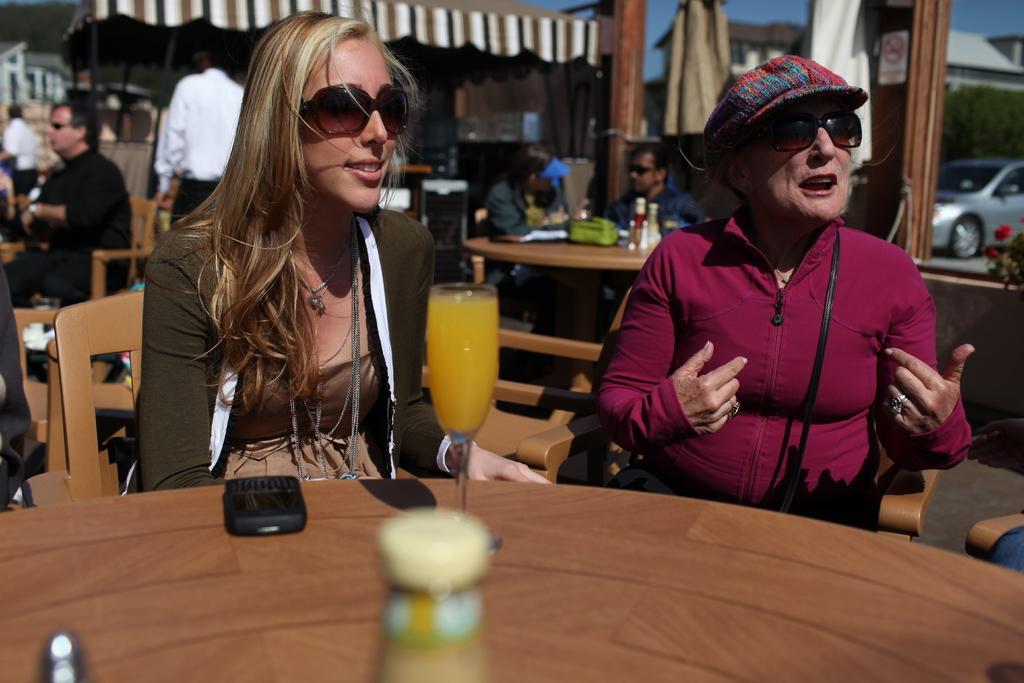Describe this image in one or two sentences. It is a restaurant, there are two women sitting in front of the table, there is a glass with juice and a mobile and a bottle on the table. First woman who is wearing pink jacket is speaking something , the woman sitting to the left is smiling behind these two people there also other people, in the background there is a car, a sky, building , few clothes hanged and a wooden pole. 